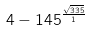Convert formula to latex. <formula><loc_0><loc_0><loc_500><loc_500>4 - 1 4 5 ^ { \frac { \sqrt { 3 3 5 } } { 1 } }</formula> 